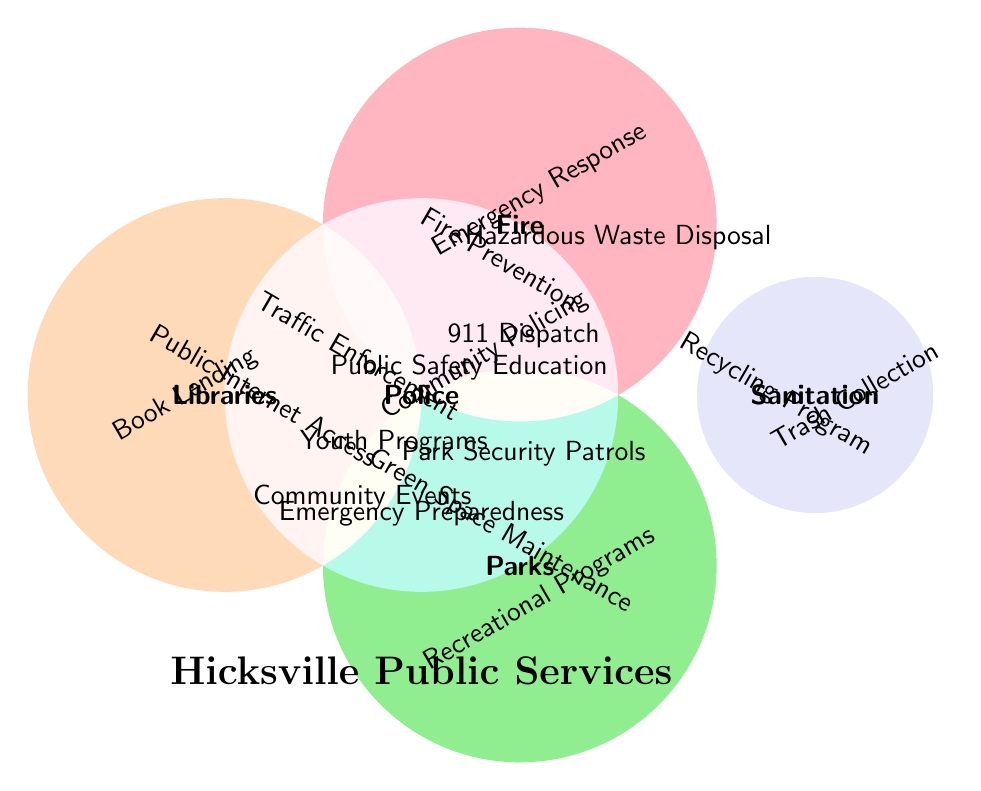What categories overlap with 'Park Security Patrols'? The figure shows 'Park Security Patrols' in the overlapping area of 'Police' and 'Parks'.
Answer: Police and Parks Which service is common to all five categories? The figure shows 'Emergency Preparedness' in the center where all five categories overlap.
Answer: Emergency Preparedness How many services are uniquely provided by just the 'Sanitation' category? 'Trash Collection' and 'Recycling Program' are in the section uniquely allocated to 'Sanitation'. There are 2 services.
Answer: 2 Which two services are common to both 'Police' and 'Fire'? The figure shows '911 Dispatch' and 'Public Safety Education' in the overlapping area between 'Police' and 'Fire'.
Answer: 911 Dispatch and Public Safety Education Is 'Community Events' a service provided by 'Libraries'? The figure shows 'Community Events' in the overlap between 'Parks' and 'Libraries', so 'Libraries' do provide 'Community Events'.
Answer: Yes How many services are exclusive to the 'Police' category? 'Community Policing' and 'Traffic Enforcement' are in the section uniquely allocated to 'Police'. There are 2 services.
Answer: 2 Which categories share the 'Hazardous Waste Disposal' service? The figure shows 'Hazardous Waste Disposal' in the overlapping area of 'Fire' and 'Sanitation'.
Answer: Fire and Sanitation Is 'Public Internet Access' a shared service or unique to a single category? The figure shows 'Public Internet Access' in the section solely associated with 'Libraries', making it unique to that category.
Answer: Unique Which service do 'Parks' and 'Libraries' collectively provide other than 'Community Events'? The figure shows 'Youth Programs' in the overlapping area between 'Parks' and 'Libraries'.
Answer: Youth Programs 